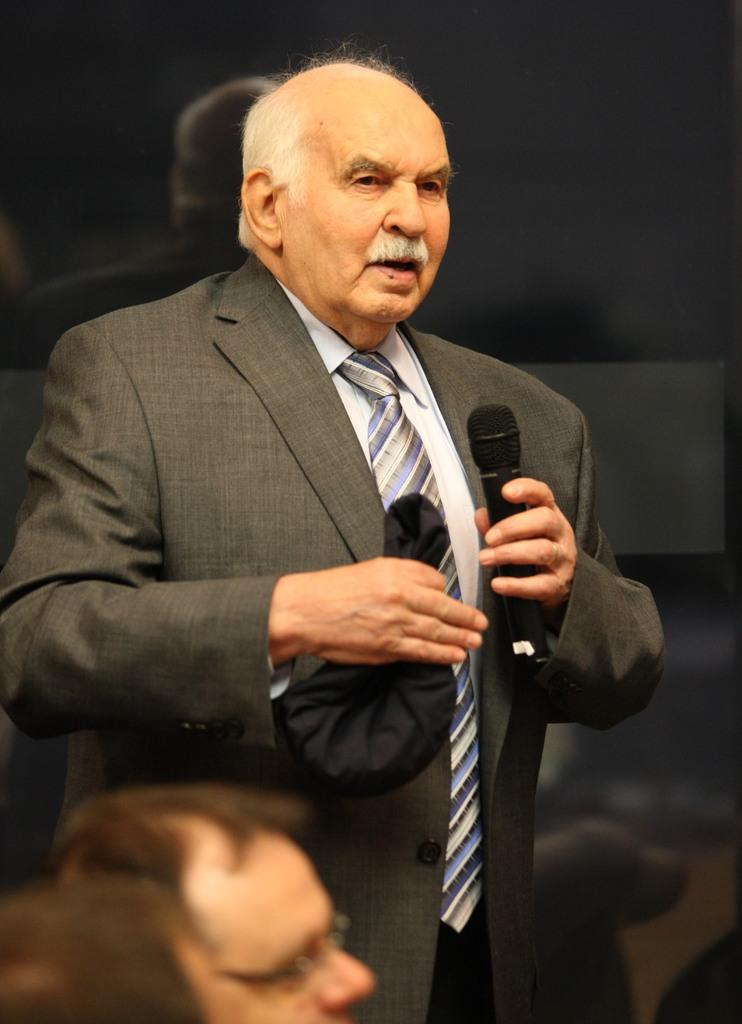What is the person in the image doing? The person is standing. What type of clothing is the person wearing? The person is wearing a coat and a tie. What object is the person holding in the image? The person is holding a microphone. What can be seen in the background of the image? There is a curtain in the background. How many horses are visible in the image? There are no horses present in the image. In which direction is the person facing in the image? The provided facts do not specify the direction the person is facing, so we cannot definitively answer this question. 